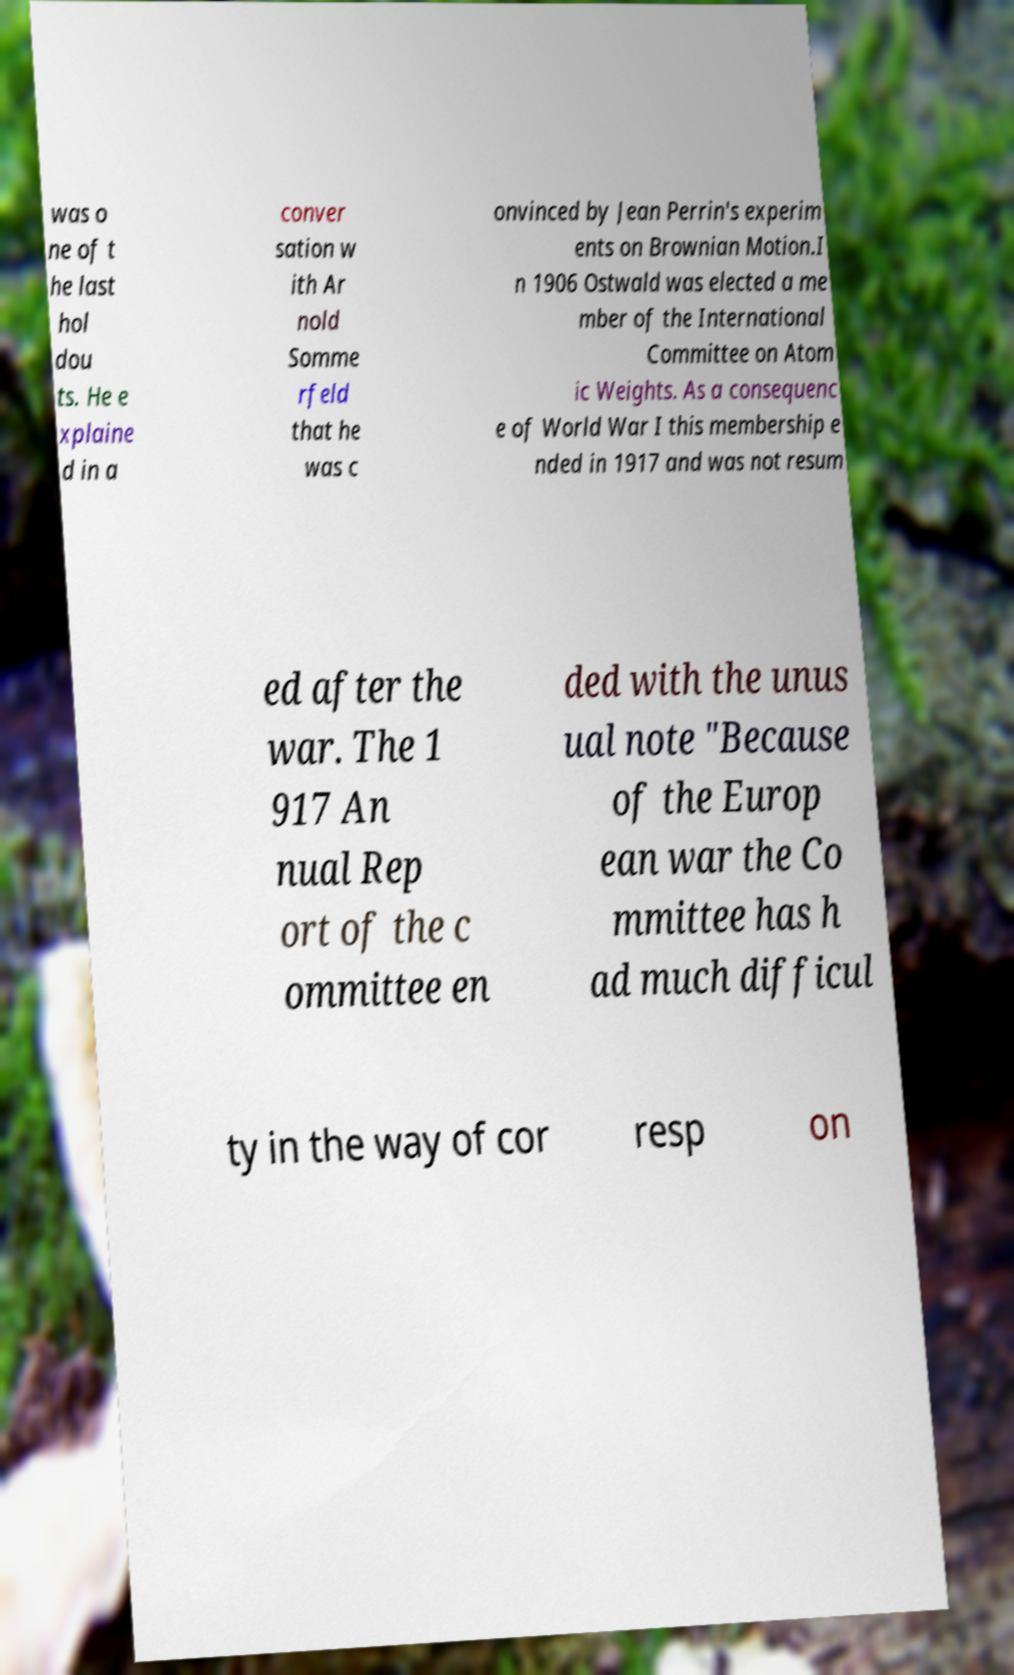I need the written content from this picture converted into text. Can you do that? was o ne of t he last hol dou ts. He e xplaine d in a conver sation w ith Ar nold Somme rfeld that he was c onvinced by Jean Perrin's experim ents on Brownian Motion.I n 1906 Ostwald was elected a me mber of the International Committee on Atom ic Weights. As a consequenc e of World War I this membership e nded in 1917 and was not resum ed after the war. The 1 917 An nual Rep ort of the c ommittee en ded with the unus ual note "Because of the Europ ean war the Co mmittee has h ad much difficul ty in the way of cor resp on 